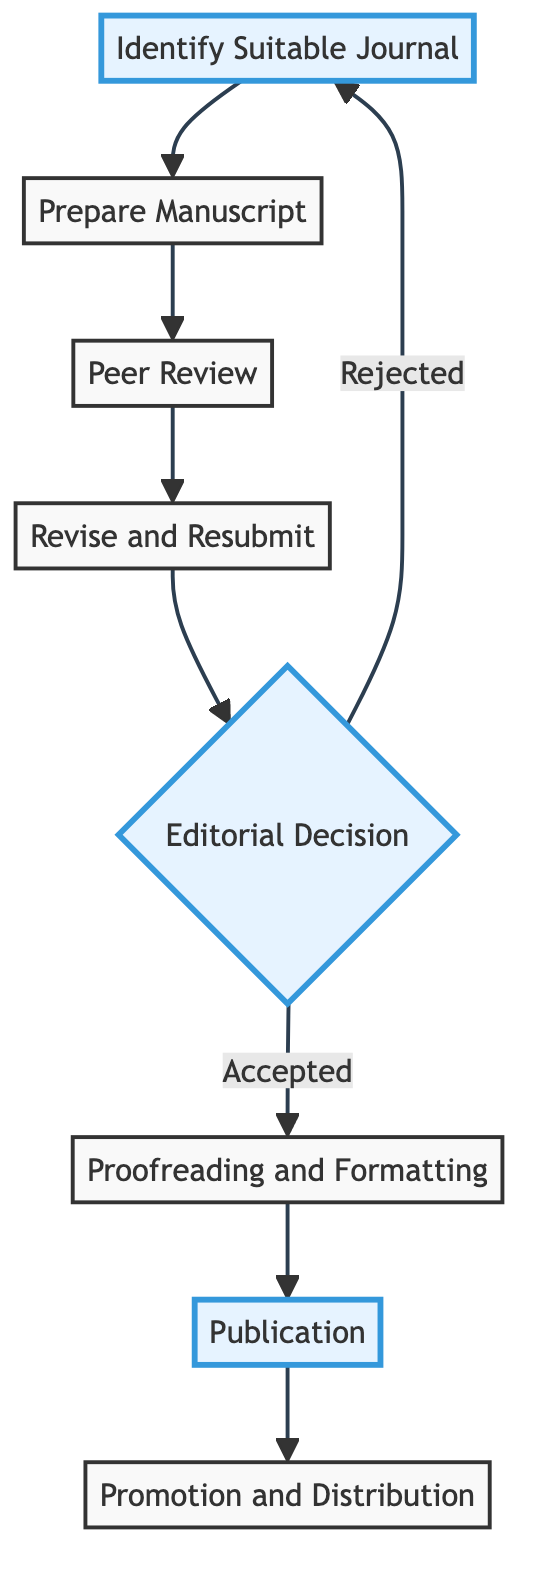What is the first step in the process? The diagram indicates that the first step is "Identify Suitable Journal," which is at the beginning of the flow.
Answer: Identify Suitable Journal How many total steps are there in the publishing process? By counting the steps in the flowchart, there are a total of eight distinct actions outlined in the process.
Answer: 8 What happens if the editorial decision is "Rejected"? The flowchart indicates that if the editorial decision is "Rejected," the process loops back to the first step, which is "Identify Suitable Journal."
Answer: Identify Suitable Journal What is the last action before publication? The step that directly precedes "Publication" is "Proofreading and Formatting," as shown by the flow from the proofreading step to publication.
Answer: Proofreading and Formatting Which step follows the "Revise and Resubmit" action? From the diagram, "Editorial Decision" is the next action after "Revise and Resubmit," as they are linked sequentially.
Answer: Editorial Decision How does the diagram depict the process of peer review? The diagram clearly illustrates that "Peer Review" follows the "Prepare Manuscript" step, indicating it is a critical part of the submission process.
Answer: Peer Review What action is suggested to take after the article is published? According to the diagram, "Promotion and Distribution" is the action to take after the article is published in the journal.
Answer: Promotion and Distribution Is there a feedback loop in the diagram? Yes, the diagram shows a feedback loop from "Editorial Decision" (if rejected) back to "Identify Suitable Journal," indicating that the process can restart from an earlier stage.
Answer: Yes 